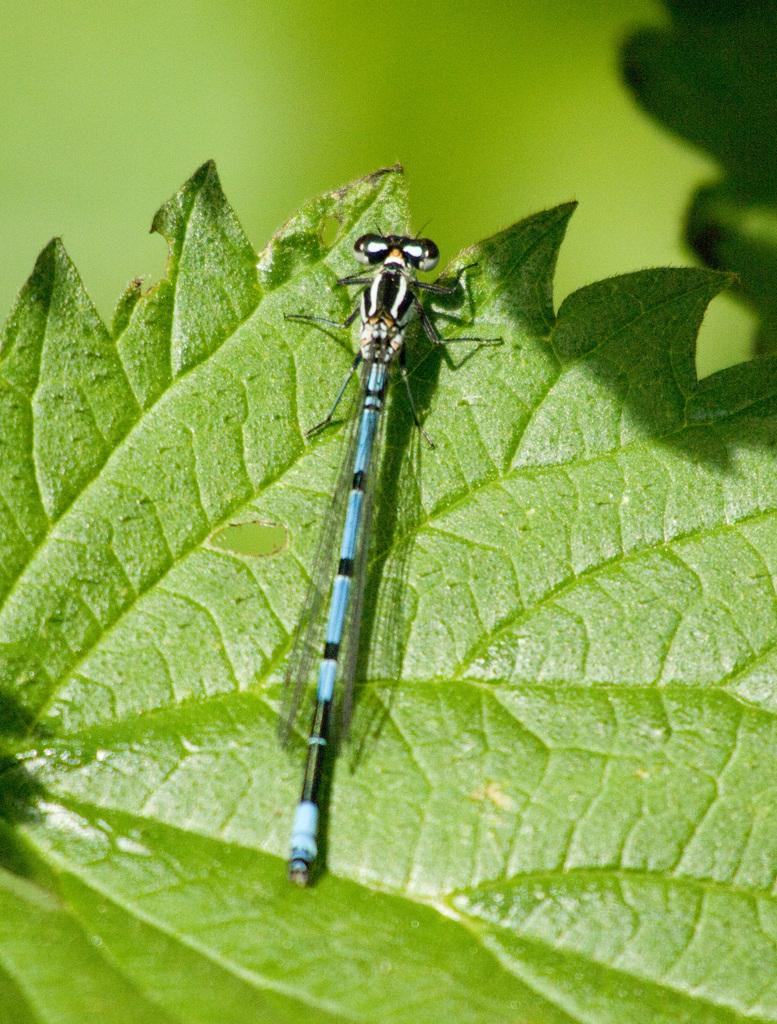What type of plant material is present in the image? There is a green leaf in the image. What other living organism can be seen in the image? There is an insect in the image. What colors are present on the insect? The insect has black, blue, and white colors. What is the dominant color in the background of the image? The background of the image is green. How many babies are visible in the image? There are no babies present in the image. What type of underground storage area is depicted in the image? There is no cellar or underground storage area depicted in the image. 